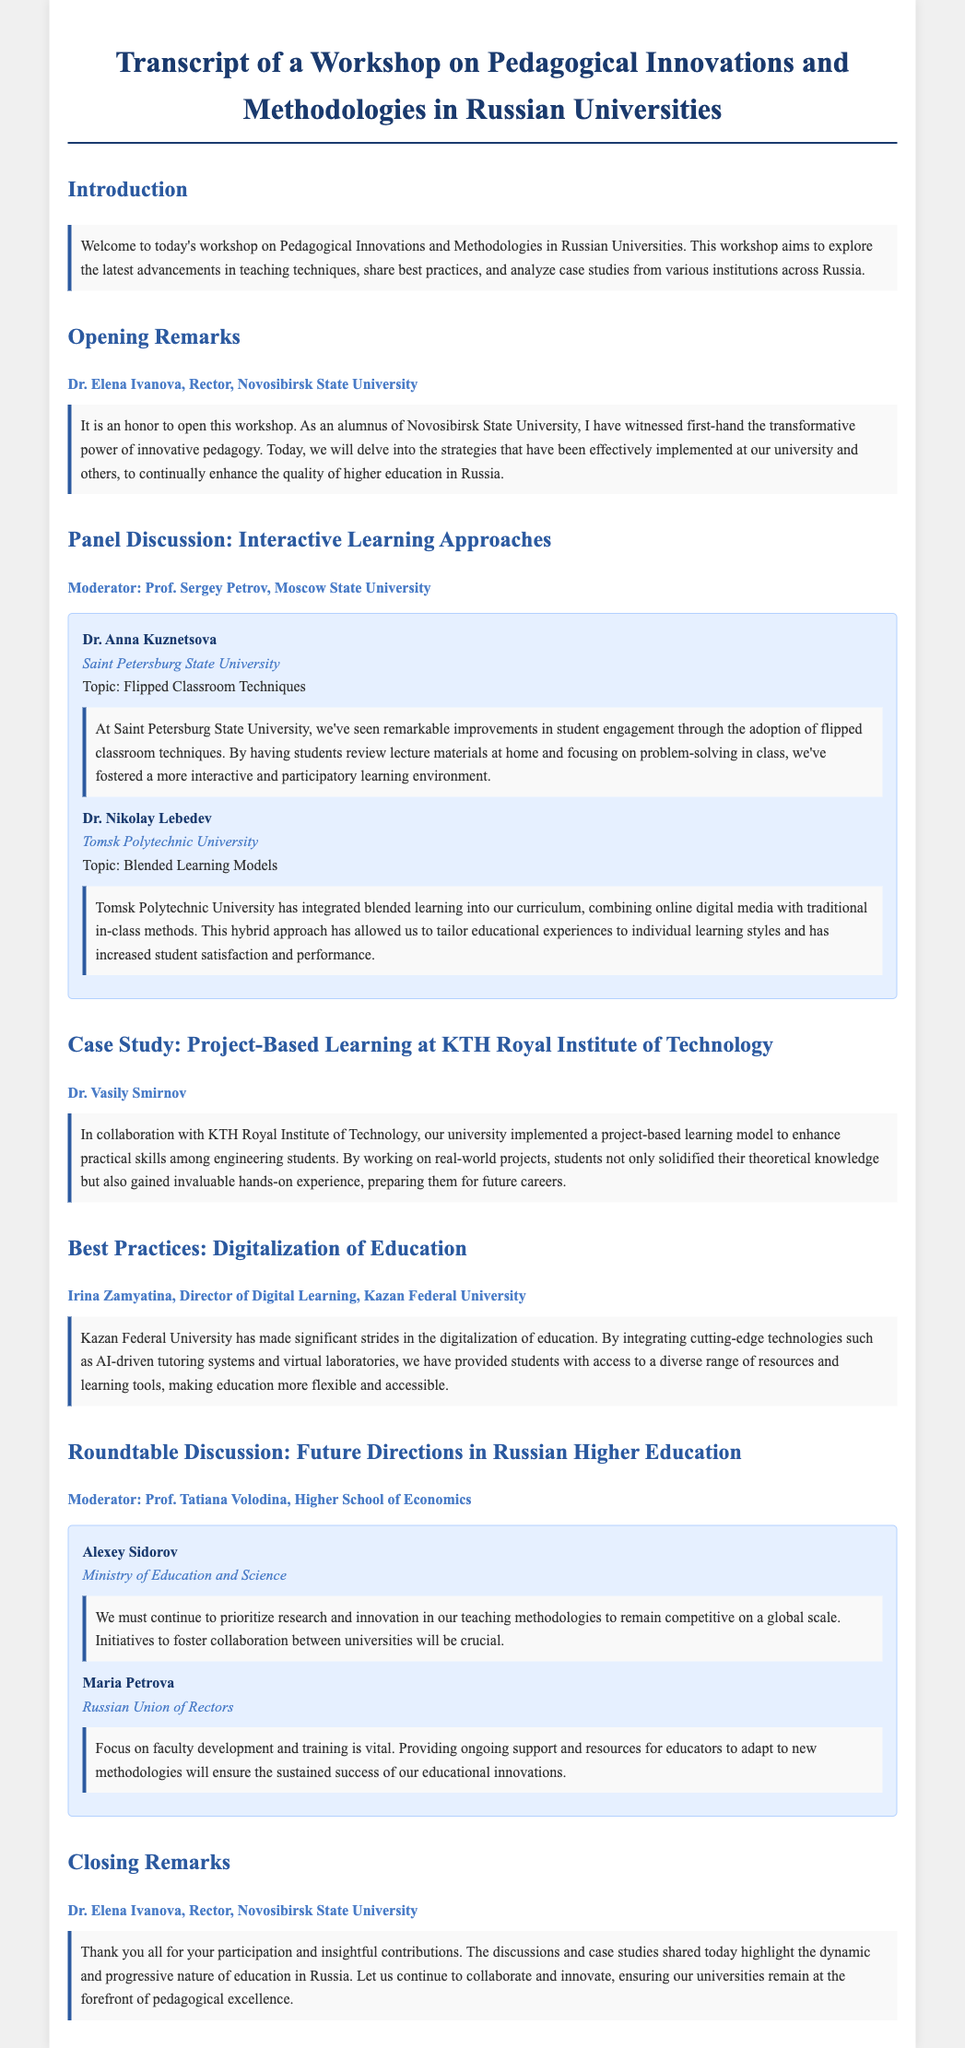What is the title of the workshop? The title is mentioned at the beginning of the document, which covers the focus on pedagogical innovations and methodologies in Russian universities.
Answer: Transcript of a Workshop on Pedagogical Innovations and Methodologies in Russian Universities Who is the Rector of Novosibirsk State University? The opening remarks are provided by Dr. Elena Ivanova, who is identified as the Rector in the document.
Answer: Dr. Elena Ivanova What innovative technique is discussed by Dr. Anna Kuznetsova? The document states the topic discussed by Dr. Anna Kuznetsova, which focuses on a specific teaching strategy implemented at her university.
Answer: Flipped Classroom Techniques Which university is collaborating with Novosibirsk State University for project-based learning? The case study section indicates that KTH Royal Institute of Technology has collaborated with Novosibirsk State University.
Answer: KTH Royal Institute of Technology What is a major focus highlighted by Alexey Sidorov during the roundtable discussion? The content shared by Alexey Sidorov emphasizes the importance of fostering collaboration between universities as a future direction.
Answer: Collaboration between universities How has Kazan Federal University enhanced the digitalization of education? The discussion on best practices illustrates the integration of specific technologies at Kazan Federal University to improve educational access and resources.
Answer: AI-driven tutoring systems and virtual laboratories What teaching model is being integrated by Tomsk Polytechnic University? In the document, Dr. Nikolay Lebedev discusses a specific learning model that combines traditional and digital methods.
Answer: Blended Learning Models 